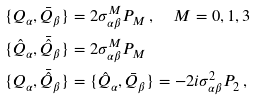<formula> <loc_0><loc_0><loc_500><loc_500>& \{ Q _ { \alpha } , \bar { Q } _ { \beta } \} = 2 \sigma ^ { M } _ { \alpha \beta } P _ { M } \, , \quad M = 0 , 1 , 3 \\ & \{ \hat { Q } _ { \alpha } , \bar { \hat { Q } } _ { \beta } \} = 2 \sigma ^ { M } _ { \alpha \beta } P _ { M } \\ & \{ Q _ { \alpha } , \bar { \hat { Q } } _ { \beta } \} = \{ \hat { Q } _ { \alpha } , \bar { Q } _ { \beta } \} = - 2 i \sigma ^ { 2 } _ { \alpha \beta } P _ { 2 } \, ,</formula> 